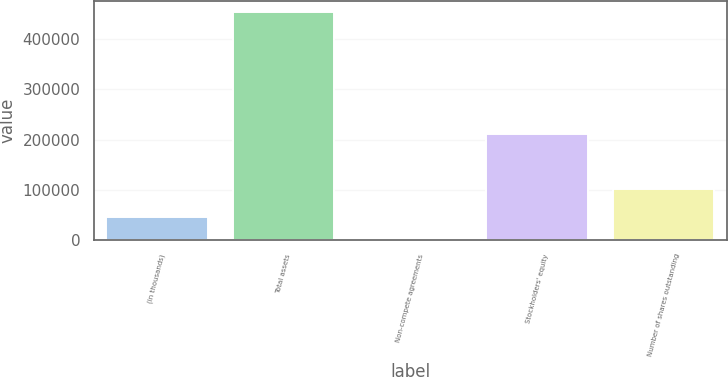<chart> <loc_0><loc_0><loc_500><loc_500><bar_chart><fcel>(in thousands)<fcel>Total assets<fcel>Non-compete agreements<fcel>Stockholders' equity<fcel>Number of shares outstanding<nl><fcel>45911.5<fcel>453175<fcel>660<fcel>211459<fcel>101837<nl></chart> 